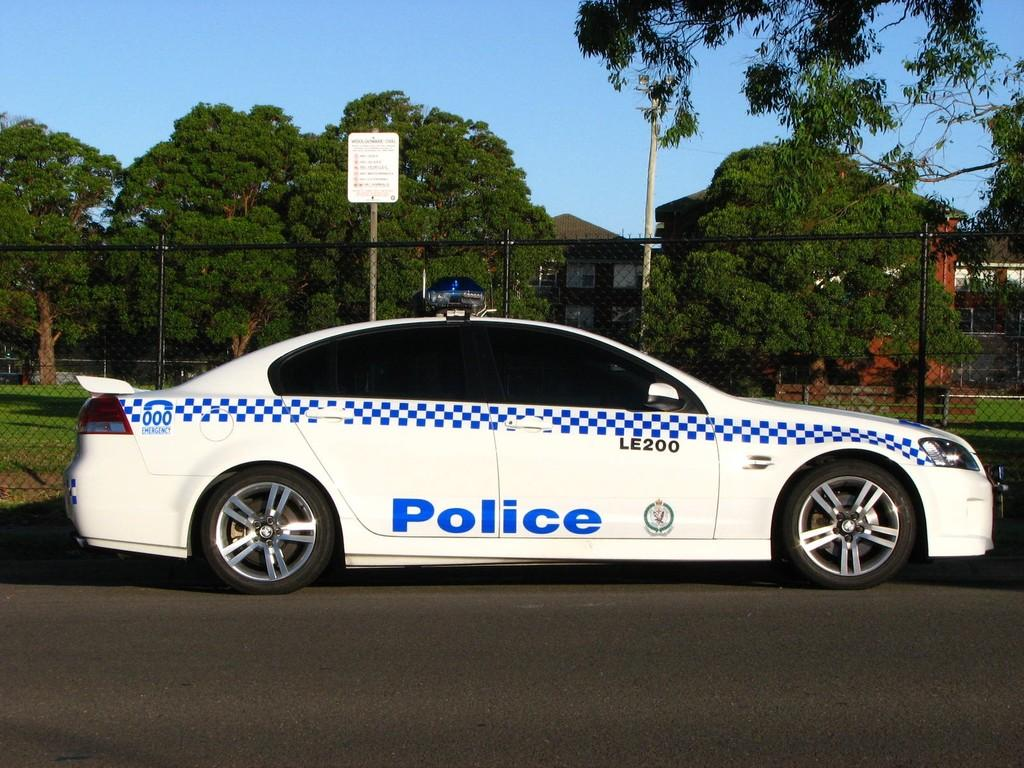What is on the road in the image? There is a car on the road in the image. What is behind the car? There is a fence behind the car. What is on a pole in the image? There is a board on a pole in the image. What can be seen in the background of the image? There are trees, grass, houses, and the sky visible in the background. What is the kitty doing with the father in the image? There is no kitty or father present in the image. What time of day is it in the image? The time of day cannot be determined from the image alone, as there are no specific clues or indicators present. 